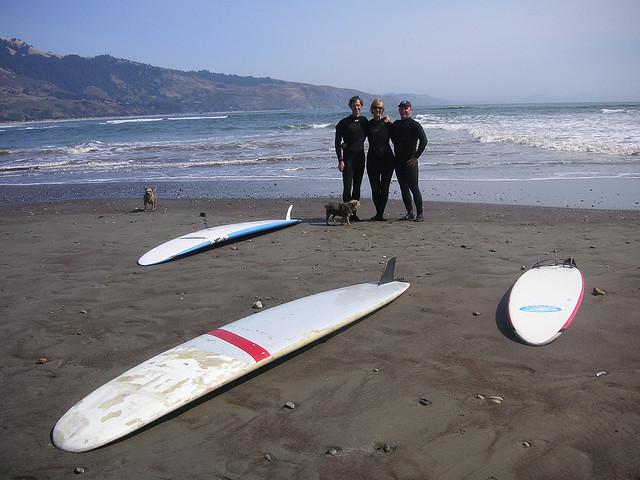How many dogs are in this photo?
Concise answer only. 2. Why are these people wearing wetsuits?
Give a very brief answer. Surfing. Where are these people?
Write a very short answer. Beach. 